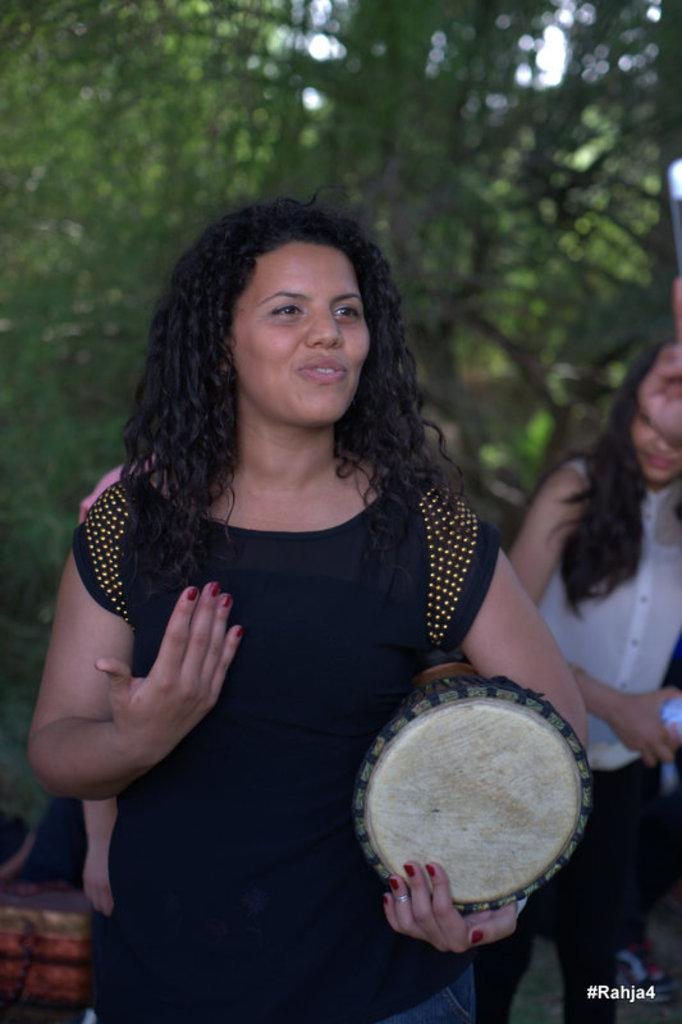What is the woman in the image wearing? The woman is wearing a black dress. What is the woman holding in the image? The woman is holding a musical instrument. What expression does the woman have in the image? The woman is smiling. What can be seen in the background of the image? There is a tree visible in the background of the image. What type of sign can be seen in the image? There is no sign present in the image; it features a woman holding a musical instrument and smiling. What kind of rice is being cooked in the image? There is no rice or cooking activity present in the image. 